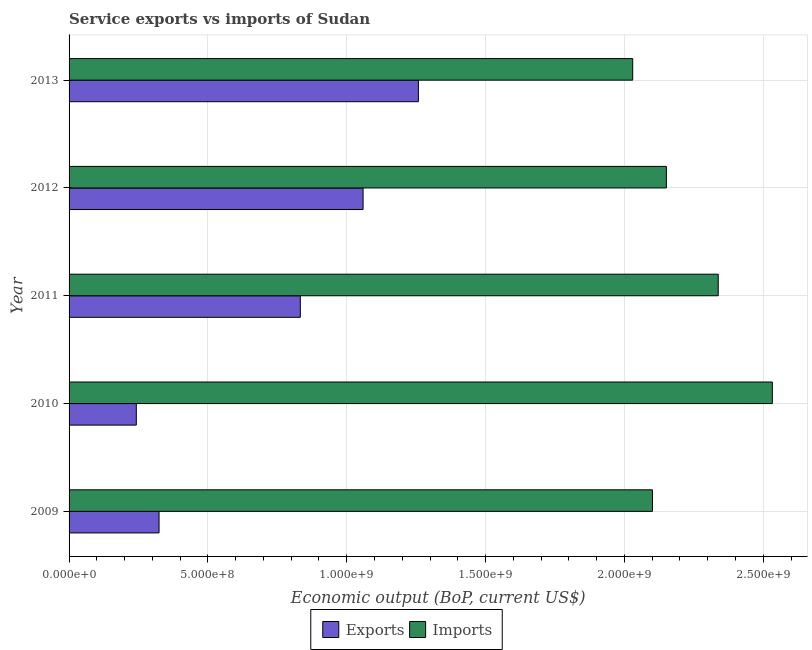How many different coloured bars are there?
Provide a short and direct response. 2. What is the label of the 2nd group of bars from the top?
Your response must be concise. 2012. In how many cases, is the number of bars for a given year not equal to the number of legend labels?
Provide a short and direct response. 0. What is the amount of service exports in 2009?
Offer a terse response. 3.24e+08. Across all years, what is the maximum amount of service exports?
Offer a terse response. 1.26e+09. Across all years, what is the minimum amount of service exports?
Offer a terse response. 2.42e+08. In which year was the amount of service imports minimum?
Offer a terse response. 2013. What is the total amount of service exports in the graph?
Your response must be concise. 3.72e+09. What is the difference between the amount of service exports in 2009 and that in 2013?
Ensure brevity in your answer.  -9.34e+08. What is the difference between the amount of service imports in 2012 and the amount of service exports in 2013?
Make the answer very short. 8.93e+08. What is the average amount of service imports per year?
Your answer should be compact. 2.23e+09. In the year 2009, what is the difference between the amount of service imports and amount of service exports?
Provide a succinct answer. 1.78e+09. In how many years, is the amount of service exports greater than 1800000000 US$?
Provide a succinct answer. 0. What is the ratio of the amount of service exports in 2009 to that in 2010?
Your answer should be compact. 1.34. Is the amount of service imports in 2009 less than that in 2012?
Offer a terse response. Yes. Is the difference between the amount of service imports in 2011 and 2012 greater than the difference between the amount of service exports in 2011 and 2012?
Make the answer very short. Yes. What is the difference between the highest and the second highest amount of service exports?
Your answer should be compact. 1.99e+08. What is the difference between the highest and the lowest amount of service exports?
Provide a short and direct response. 1.02e+09. In how many years, is the amount of service imports greater than the average amount of service imports taken over all years?
Offer a very short reply. 2. What does the 2nd bar from the top in 2013 represents?
Your answer should be compact. Exports. What does the 1st bar from the bottom in 2011 represents?
Your answer should be very brief. Exports. Are all the bars in the graph horizontal?
Your answer should be very brief. Yes. What is the difference between two consecutive major ticks on the X-axis?
Make the answer very short. 5.00e+08. Are the values on the major ticks of X-axis written in scientific E-notation?
Provide a succinct answer. Yes. Does the graph contain any zero values?
Your response must be concise. No. Does the graph contain grids?
Your response must be concise. Yes. Where does the legend appear in the graph?
Make the answer very short. Bottom center. What is the title of the graph?
Your answer should be compact. Service exports vs imports of Sudan. Does "Death rate" appear as one of the legend labels in the graph?
Your answer should be compact. No. What is the label or title of the X-axis?
Give a very brief answer. Economic output (BoP, current US$). What is the label or title of the Y-axis?
Make the answer very short. Year. What is the Economic output (BoP, current US$) of Exports in 2009?
Give a very brief answer. 3.24e+08. What is the Economic output (BoP, current US$) of Imports in 2009?
Your response must be concise. 2.10e+09. What is the Economic output (BoP, current US$) in Exports in 2010?
Ensure brevity in your answer.  2.42e+08. What is the Economic output (BoP, current US$) of Imports in 2010?
Make the answer very short. 2.53e+09. What is the Economic output (BoP, current US$) in Exports in 2011?
Offer a terse response. 8.33e+08. What is the Economic output (BoP, current US$) in Imports in 2011?
Give a very brief answer. 2.34e+09. What is the Economic output (BoP, current US$) of Exports in 2012?
Give a very brief answer. 1.06e+09. What is the Economic output (BoP, current US$) in Imports in 2012?
Provide a succinct answer. 2.15e+09. What is the Economic output (BoP, current US$) of Exports in 2013?
Offer a terse response. 1.26e+09. What is the Economic output (BoP, current US$) of Imports in 2013?
Keep it short and to the point. 2.03e+09. Across all years, what is the maximum Economic output (BoP, current US$) of Exports?
Your answer should be compact. 1.26e+09. Across all years, what is the maximum Economic output (BoP, current US$) in Imports?
Offer a very short reply. 2.53e+09. Across all years, what is the minimum Economic output (BoP, current US$) in Exports?
Give a very brief answer. 2.42e+08. Across all years, what is the minimum Economic output (BoP, current US$) in Imports?
Make the answer very short. 2.03e+09. What is the total Economic output (BoP, current US$) of Exports in the graph?
Provide a short and direct response. 3.72e+09. What is the total Economic output (BoP, current US$) in Imports in the graph?
Keep it short and to the point. 1.12e+1. What is the difference between the Economic output (BoP, current US$) in Exports in 2009 and that in 2010?
Make the answer very short. 8.19e+07. What is the difference between the Economic output (BoP, current US$) of Imports in 2009 and that in 2010?
Your response must be concise. -4.32e+08. What is the difference between the Economic output (BoP, current US$) in Exports in 2009 and that in 2011?
Provide a succinct answer. -5.09e+08. What is the difference between the Economic output (BoP, current US$) of Imports in 2009 and that in 2011?
Your answer should be very brief. -2.37e+08. What is the difference between the Economic output (BoP, current US$) in Exports in 2009 and that in 2012?
Your answer should be compact. -7.35e+08. What is the difference between the Economic output (BoP, current US$) in Imports in 2009 and that in 2012?
Offer a terse response. -5.01e+07. What is the difference between the Economic output (BoP, current US$) in Exports in 2009 and that in 2013?
Give a very brief answer. -9.34e+08. What is the difference between the Economic output (BoP, current US$) of Imports in 2009 and that in 2013?
Offer a very short reply. 7.12e+07. What is the difference between the Economic output (BoP, current US$) in Exports in 2010 and that in 2011?
Ensure brevity in your answer.  -5.91e+08. What is the difference between the Economic output (BoP, current US$) in Imports in 2010 and that in 2011?
Make the answer very short. 1.95e+08. What is the difference between the Economic output (BoP, current US$) of Exports in 2010 and that in 2012?
Provide a succinct answer. -8.17e+08. What is the difference between the Economic output (BoP, current US$) of Imports in 2010 and that in 2012?
Ensure brevity in your answer.  3.82e+08. What is the difference between the Economic output (BoP, current US$) of Exports in 2010 and that in 2013?
Provide a short and direct response. -1.02e+09. What is the difference between the Economic output (BoP, current US$) in Imports in 2010 and that in 2013?
Make the answer very short. 5.03e+08. What is the difference between the Economic output (BoP, current US$) in Exports in 2011 and that in 2012?
Provide a succinct answer. -2.26e+08. What is the difference between the Economic output (BoP, current US$) in Imports in 2011 and that in 2012?
Your answer should be very brief. 1.87e+08. What is the difference between the Economic output (BoP, current US$) of Exports in 2011 and that in 2013?
Provide a short and direct response. -4.25e+08. What is the difference between the Economic output (BoP, current US$) in Imports in 2011 and that in 2013?
Ensure brevity in your answer.  3.08e+08. What is the difference between the Economic output (BoP, current US$) of Exports in 2012 and that in 2013?
Give a very brief answer. -1.99e+08. What is the difference between the Economic output (BoP, current US$) in Imports in 2012 and that in 2013?
Keep it short and to the point. 1.21e+08. What is the difference between the Economic output (BoP, current US$) in Exports in 2009 and the Economic output (BoP, current US$) in Imports in 2010?
Make the answer very short. -2.21e+09. What is the difference between the Economic output (BoP, current US$) in Exports in 2009 and the Economic output (BoP, current US$) in Imports in 2011?
Make the answer very short. -2.01e+09. What is the difference between the Economic output (BoP, current US$) in Exports in 2009 and the Economic output (BoP, current US$) in Imports in 2012?
Your answer should be very brief. -1.83e+09. What is the difference between the Economic output (BoP, current US$) in Exports in 2009 and the Economic output (BoP, current US$) in Imports in 2013?
Offer a very short reply. -1.71e+09. What is the difference between the Economic output (BoP, current US$) in Exports in 2010 and the Economic output (BoP, current US$) in Imports in 2011?
Your answer should be compact. -2.10e+09. What is the difference between the Economic output (BoP, current US$) of Exports in 2010 and the Economic output (BoP, current US$) of Imports in 2012?
Offer a terse response. -1.91e+09. What is the difference between the Economic output (BoP, current US$) in Exports in 2010 and the Economic output (BoP, current US$) in Imports in 2013?
Offer a very short reply. -1.79e+09. What is the difference between the Economic output (BoP, current US$) in Exports in 2011 and the Economic output (BoP, current US$) in Imports in 2012?
Ensure brevity in your answer.  -1.32e+09. What is the difference between the Economic output (BoP, current US$) in Exports in 2011 and the Economic output (BoP, current US$) in Imports in 2013?
Ensure brevity in your answer.  -1.20e+09. What is the difference between the Economic output (BoP, current US$) in Exports in 2012 and the Economic output (BoP, current US$) in Imports in 2013?
Offer a very short reply. -9.71e+08. What is the average Economic output (BoP, current US$) in Exports per year?
Provide a succinct answer. 7.43e+08. What is the average Economic output (BoP, current US$) in Imports per year?
Your answer should be very brief. 2.23e+09. In the year 2009, what is the difference between the Economic output (BoP, current US$) of Exports and Economic output (BoP, current US$) of Imports?
Offer a terse response. -1.78e+09. In the year 2010, what is the difference between the Economic output (BoP, current US$) in Exports and Economic output (BoP, current US$) in Imports?
Offer a very short reply. -2.29e+09. In the year 2011, what is the difference between the Economic output (BoP, current US$) of Exports and Economic output (BoP, current US$) of Imports?
Your response must be concise. -1.50e+09. In the year 2012, what is the difference between the Economic output (BoP, current US$) in Exports and Economic output (BoP, current US$) in Imports?
Offer a very short reply. -1.09e+09. In the year 2013, what is the difference between the Economic output (BoP, current US$) in Exports and Economic output (BoP, current US$) in Imports?
Make the answer very short. -7.72e+08. What is the ratio of the Economic output (BoP, current US$) in Exports in 2009 to that in 2010?
Your answer should be compact. 1.34. What is the ratio of the Economic output (BoP, current US$) in Imports in 2009 to that in 2010?
Your response must be concise. 0.83. What is the ratio of the Economic output (BoP, current US$) in Exports in 2009 to that in 2011?
Provide a succinct answer. 0.39. What is the ratio of the Economic output (BoP, current US$) of Imports in 2009 to that in 2011?
Your response must be concise. 0.9. What is the ratio of the Economic output (BoP, current US$) in Exports in 2009 to that in 2012?
Offer a terse response. 0.31. What is the ratio of the Economic output (BoP, current US$) in Imports in 2009 to that in 2012?
Your answer should be compact. 0.98. What is the ratio of the Economic output (BoP, current US$) in Exports in 2009 to that in 2013?
Ensure brevity in your answer.  0.26. What is the ratio of the Economic output (BoP, current US$) in Imports in 2009 to that in 2013?
Give a very brief answer. 1.04. What is the ratio of the Economic output (BoP, current US$) of Exports in 2010 to that in 2011?
Offer a terse response. 0.29. What is the ratio of the Economic output (BoP, current US$) in Exports in 2010 to that in 2012?
Provide a short and direct response. 0.23. What is the ratio of the Economic output (BoP, current US$) of Imports in 2010 to that in 2012?
Ensure brevity in your answer.  1.18. What is the ratio of the Economic output (BoP, current US$) in Exports in 2010 to that in 2013?
Provide a short and direct response. 0.19. What is the ratio of the Economic output (BoP, current US$) of Imports in 2010 to that in 2013?
Give a very brief answer. 1.25. What is the ratio of the Economic output (BoP, current US$) in Exports in 2011 to that in 2012?
Offer a terse response. 0.79. What is the ratio of the Economic output (BoP, current US$) of Imports in 2011 to that in 2012?
Your answer should be very brief. 1.09. What is the ratio of the Economic output (BoP, current US$) of Exports in 2011 to that in 2013?
Ensure brevity in your answer.  0.66. What is the ratio of the Economic output (BoP, current US$) in Imports in 2011 to that in 2013?
Offer a very short reply. 1.15. What is the ratio of the Economic output (BoP, current US$) in Exports in 2012 to that in 2013?
Your answer should be very brief. 0.84. What is the ratio of the Economic output (BoP, current US$) of Imports in 2012 to that in 2013?
Give a very brief answer. 1.06. What is the difference between the highest and the second highest Economic output (BoP, current US$) in Exports?
Make the answer very short. 1.99e+08. What is the difference between the highest and the second highest Economic output (BoP, current US$) in Imports?
Your response must be concise. 1.95e+08. What is the difference between the highest and the lowest Economic output (BoP, current US$) in Exports?
Give a very brief answer. 1.02e+09. What is the difference between the highest and the lowest Economic output (BoP, current US$) in Imports?
Provide a succinct answer. 5.03e+08. 